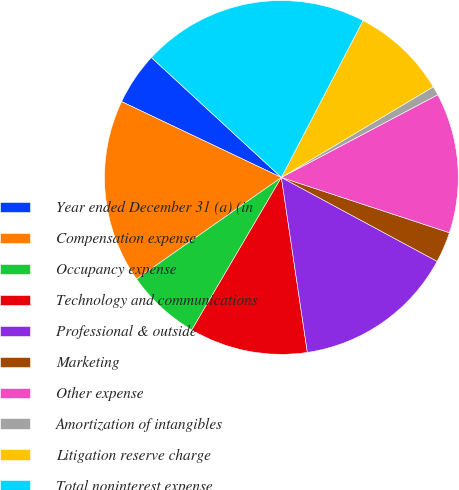<chart> <loc_0><loc_0><loc_500><loc_500><pie_chart><fcel>Year ended December 31 (a) (in<fcel>Compensation expense<fcel>Occupancy expense<fcel>Technology and communications<fcel>Professional & outside<fcel>Marketing<fcel>Other expense<fcel>Amortization of intangibles<fcel>Litigation reserve charge<fcel>Total noninterest expense<nl><fcel>4.81%<fcel>16.79%<fcel>6.81%<fcel>10.8%<fcel>14.79%<fcel>2.81%<fcel>12.8%<fcel>0.82%<fcel>8.8%<fcel>20.78%<nl></chart> 